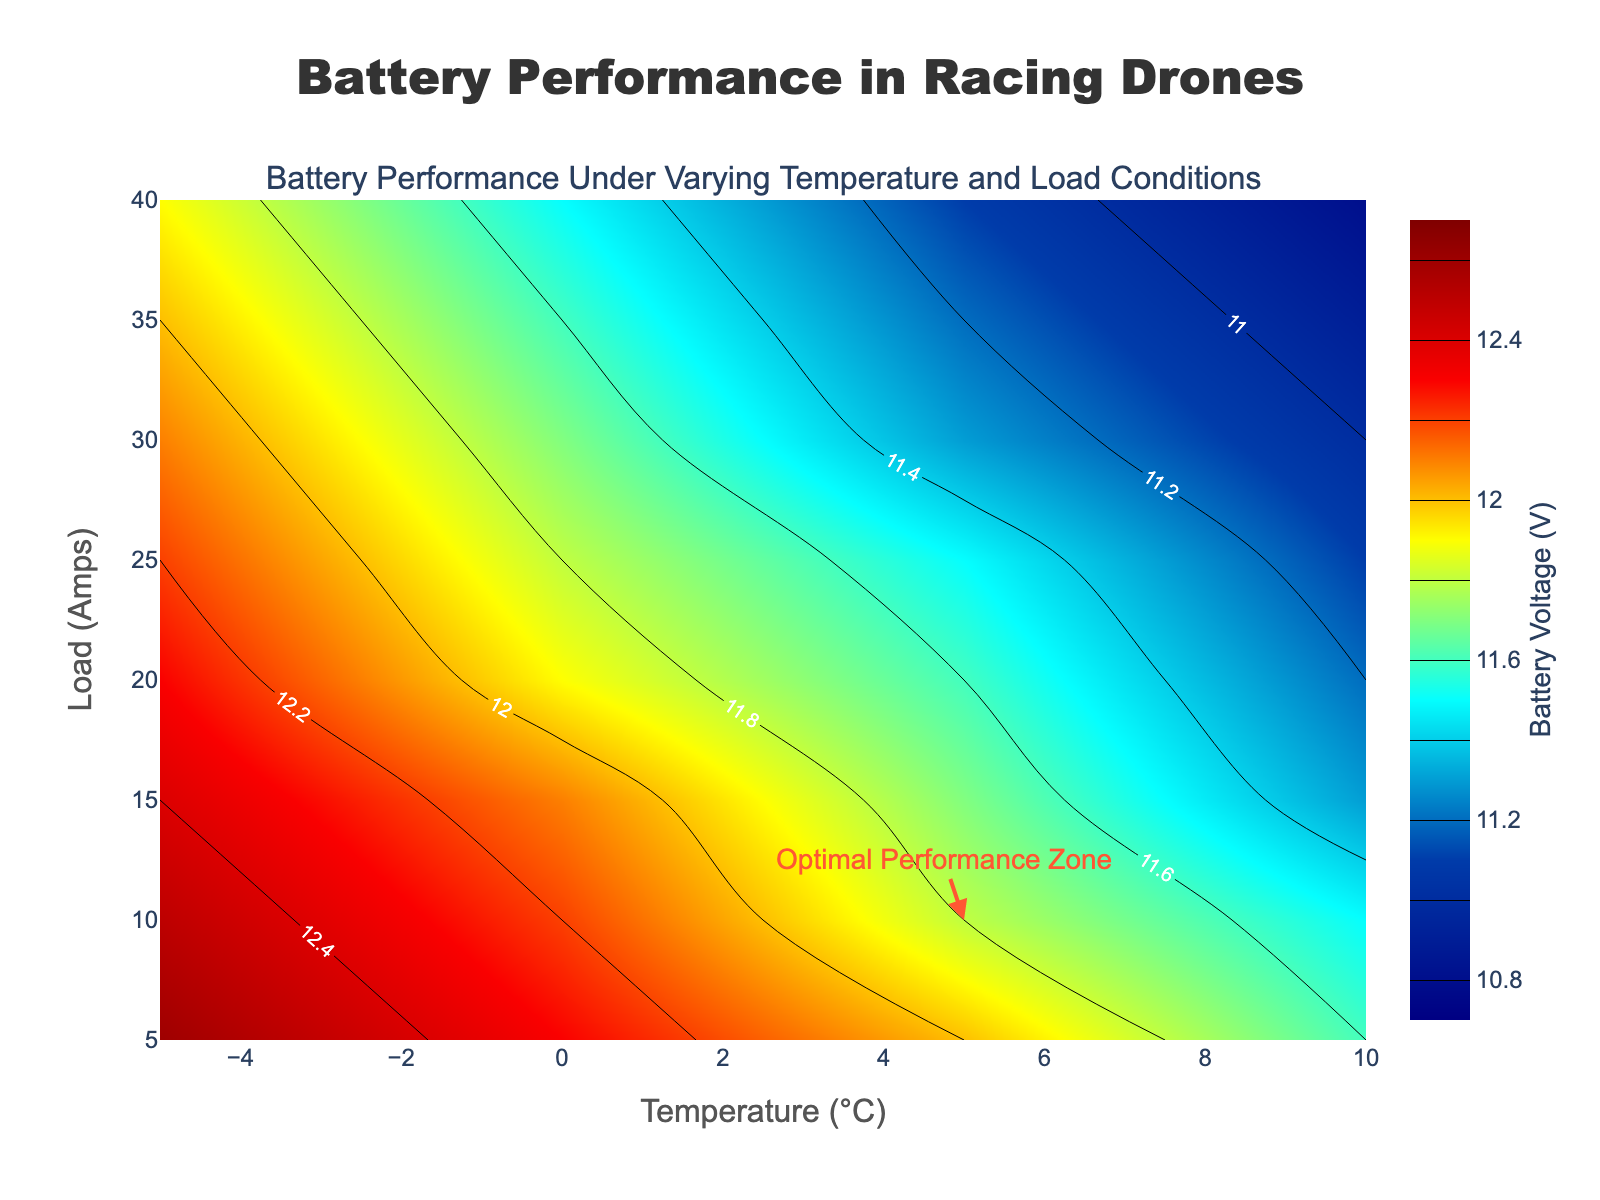What is the title of the plot? The title of the plot can be found at the top center of the figure. It reads "Battery Performance in Racing Drones".
Answer: Battery Performance in Racing Drones What does the color bar represent? The color bar on the right side of the plot is labeled with "Battery Voltage (V)", indicating that it represents the battery voltage in volts.
Answer: Battery voltage (V) Which Temperature (°C) range is shown on the x-axis? The x-axis represents the Temperature (°C) and ranges from -5 to 30. We can see this range is labeled on the x-axis.
Answer: -5 to 30 Which Load (Amps) range is shown on the y-axis? The y-axis represents the Load (Amps) and ranges from 5 to 20. These values are labeled along the y-axis.
Answer: 5 to 20 What is the approximate battery voltage at 15°C and 10 Amps? To find the approximate battery voltage at a specific point, locate the intersection of 15°C on the x-axis and 10 Amps on the y-axis within the contour plot. From the labeled contours, the voltage is approximately 11.8V.
Answer: 11.8V At which temperature and load is the battery voltage the highest? The highest battery voltage can be identified by looking at the contours close to the top right of the color bar, which correspond to the highest voltage value (12.6V). The highest voltage appears at -5°C and 5 Amps.
Answer: -5°C, 5 Amps How does the battery voltage change as the temperature increases at a constant load of 5 Amps? Trace along the y-axis at a constant load of 5 Amps from -5°C to 30°C. You can see that the battery voltage decreases from about 12.6V to about 11.9V as the temperature increases.
Answer: Decreases Which load condition shows the most significant drop in battery voltage as temperature increases from -5°C to 30°C? Compare the battery voltage change along the entire temperature gradient for each load. The load condition of 20 Amps shows the most significant drop, from approximately 11.6V to 10.8V.
Answer: 20 Amps What is the labeled "Optimal Performance Zone" and where is it located? The annotation "Optimal Performance Zone" is shown at 5°C and 10 Amps. This suggests that the optimal performance of the battery occurs around that temperature and load.
Answer: 5°C, 10 Amps What is the voltage difference between the highest and lowest battery performance zones shown in the plot? The highest voltage zone can be observed at approximately 12.6V, and the lowest voltage occurs around 10.8V. Therefore, the voltage difference is 12.6V - 10.8V = 1.8V.
Answer: 1.8V 